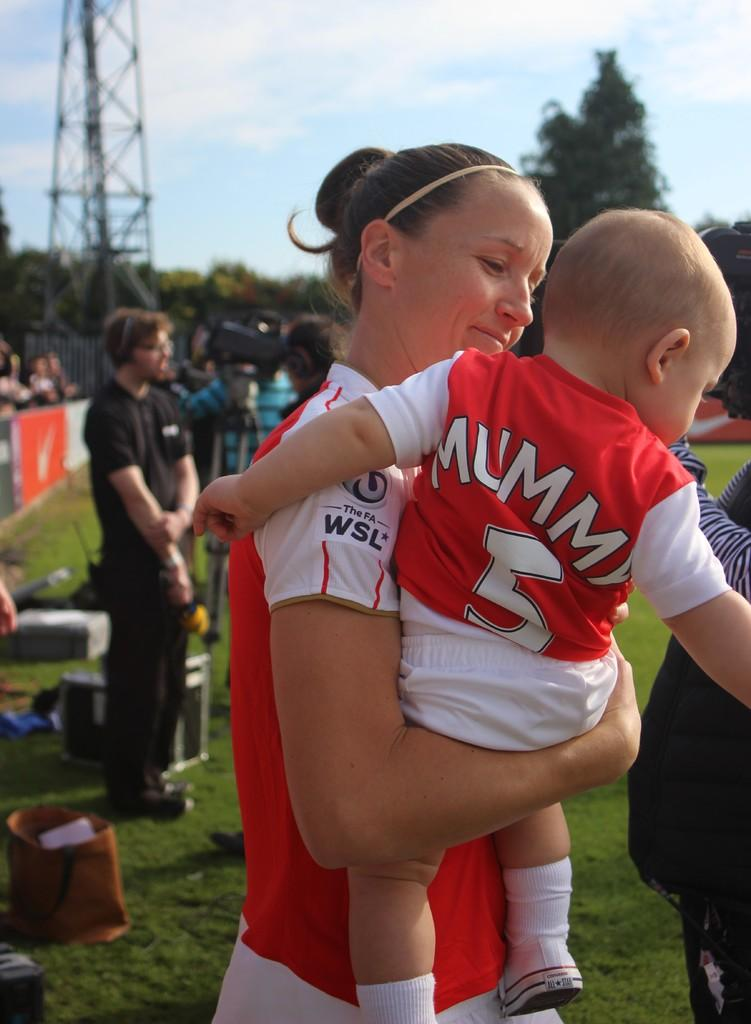Provide a one-sentence caption for the provided image. A mother holds her child with a jersey saying Mummy and the number 5. 